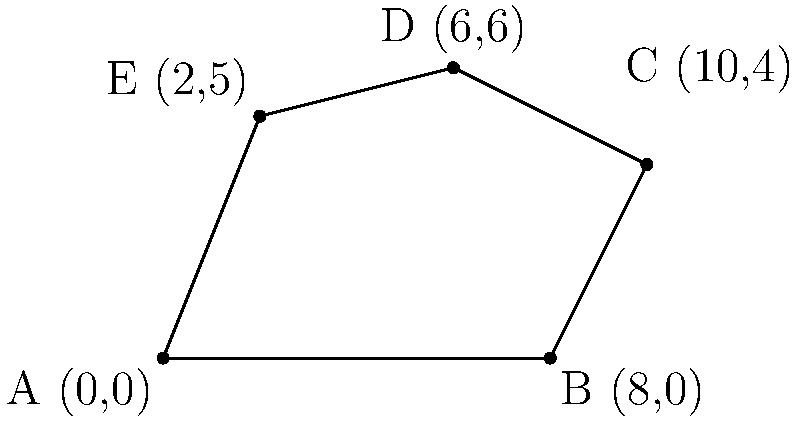Calculate the area of the irregularly shaped land plot ABCDE using coordinate geometry. The coordinates of the vertices are A(0,0), B(8,0), C(10,4), D(6,6), and E(2,5). To calculate the area of an irregular polygon using coordinate geometry, we can use the Shoelace formula (also known as the surveyor's formula). The steps are as follows:

1) List the coordinates in order (clockwise or counterclockwise):
   (0,0), (8,0), (10,4), (6,6), (2,5), (0,0)

2) Multiply each x-coordinate by the next y-coordinate:
   $0 \cdot 0 + 8 \cdot 4 + 10 \cdot 6 + 6 \cdot 5 + 2 \cdot 0 + 0 \cdot 0 = 32 + 60 + 30 = 122$

3) Multiply each y-coordinate by the next x-coordinate:
   $0 \cdot 8 + 0 \cdot 10 + 4 \cdot 6 + 6 \cdot 2 + 5 \cdot 0 + 0 \cdot 0 = 24 + 12 = 36$

4) Subtract the second sum from the first:
   $122 - 36 = 86$

5) Divide the result by 2 to get the area:
   $\text{Area} = \frac{86}{2} = 43$

Therefore, the area of the irregularly shaped land plot is 43 square units.
Answer: 43 square units 